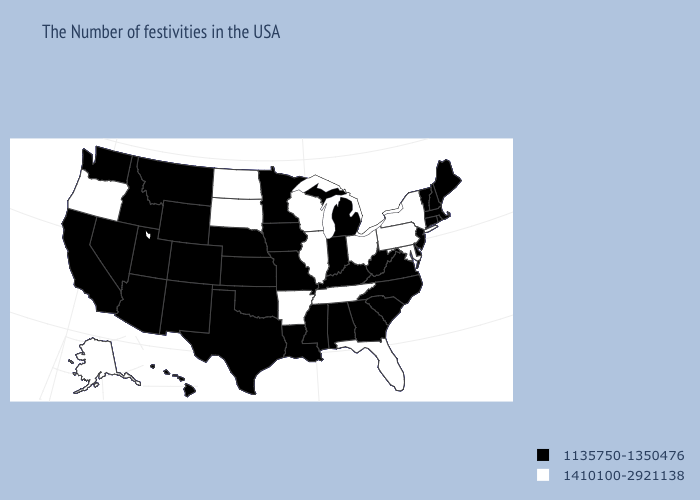Which states hav the highest value in the Northeast?
Write a very short answer. New York, Pennsylvania. Does the first symbol in the legend represent the smallest category?
Write a very short answer. Yes. What is the highest value in the South ?
Write a very short answer. 1410100-2921138. Which states have the lowest value in the USA?
Answer briefly. Maine, Massachusetts, Rhode Island, New Hampshire, Vermont, Connecticut, New Jersey, Delaware, Virginia, North Carolina, South Carolina, West Virginia, Georgia, Michigan, Kentucky, Indiana, Alabama, Mississippi, Louisiana, Missouri, Minnesota, Iowa, Kansas, Nebraska, Oklahoma, Texas, Wyoming, Colorado, New Mexico, Utah, Montana, Arizona, Idaho, Nevada, California, Washington, Hawaii. Does the first symbol in the legend represent the smallest category?
Keep it brief. Yes. What is the lowest value in the South?
Quick response, please. 1135750-1350476. Among the states that border North Dakota , which have the highest value?
Write a very short answer. South Dakota. What is the lowest value in the MidWest?
Write a very short answer. 1135750-1350476. Name the states that have a value in the range 1410100-2921138?
Write a very short answer. New York, Maryland, Pennsylvania, Ohio, Florida, Tennessee, Wisconsin, Illinois, Arkansas, South Dakota, North Dakota, Oregon, Alaska. Does Florida have the highest value in the USA?
Be succinct. Yes. Does Illinois have the highest value in the MidWest?
Concise answer only. Yes. Does Kentucky have the same value as Arkansas?
Write a very short answer. No. Which states have the highest value in the USA?
Answer briefly. New York, Maryland, Pennsylvania, Ohio, Florida, Tennessee, Wisconsin, Illinois, Arkansas, South Dakota, North Dakota, Oregon, Alaska. Name the states that have a value in the range 1410100-2921138?
Answer briefly. New York, Maryland, Pennsylvania, Ohio, Florida, Tennessee, Wisconsin, Illinois, Arkansas, South Dakota, North Dakota, Oregon, Alaska. Which states have the highest value in the USA?
Be succinct. New York, Maryland, Pennsylvania, Ohio, Florida, Tennessee, Wisconsin, Illinois, Arkansas, South Dakota, North Dakota, Oregon, Alaska. 